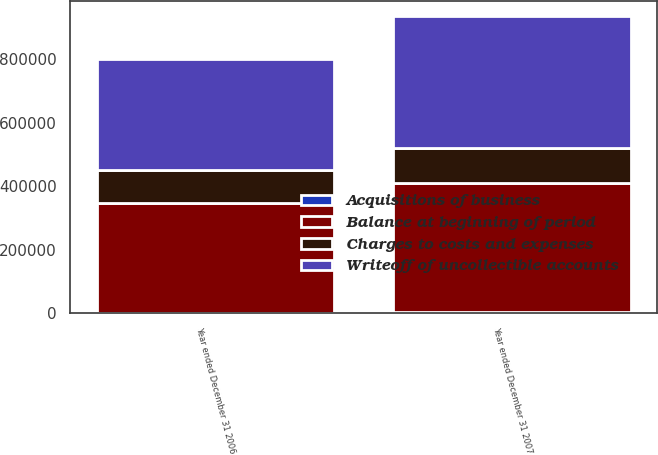Convert chart to OTSL. <chart><loc_0><loc_0><loc_500><loc_500><stacked_bar_chart><ecel><fcel>Year ended December 31 2007<fcel>Year ended December 31 2006<nl><fcel>Charges to costs and expenses<fcel>110324<fcel>105345<nl><fcel>Writeoff of uncollectible accounts<fcel>415961<fcel>349030<nl><fcel>Acquisitions of business<fcel>2452<fcel>771<nl><fcel>Balance at beginning of period<fcel>407416<fcel>344822<nl></chart> 